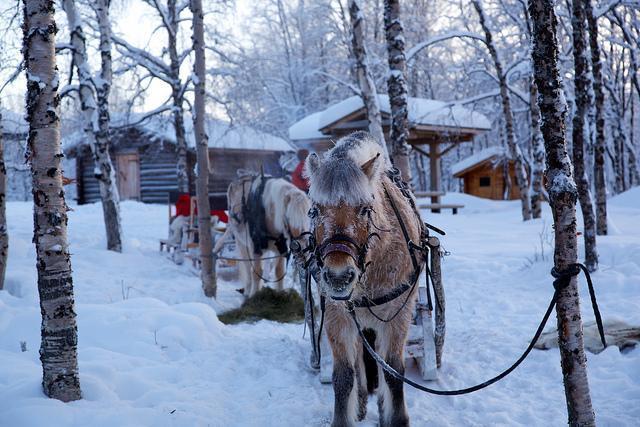How many horses are there?
Give a very brief answer. 2. 